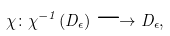<formula> <loc_0><loc_0><loc_500><loc_500>\chi \colon \chi ^ { - 1 } ( D _ { \epsilon } ) \longrightarrow D _ { \epsilon } ,</formula> 